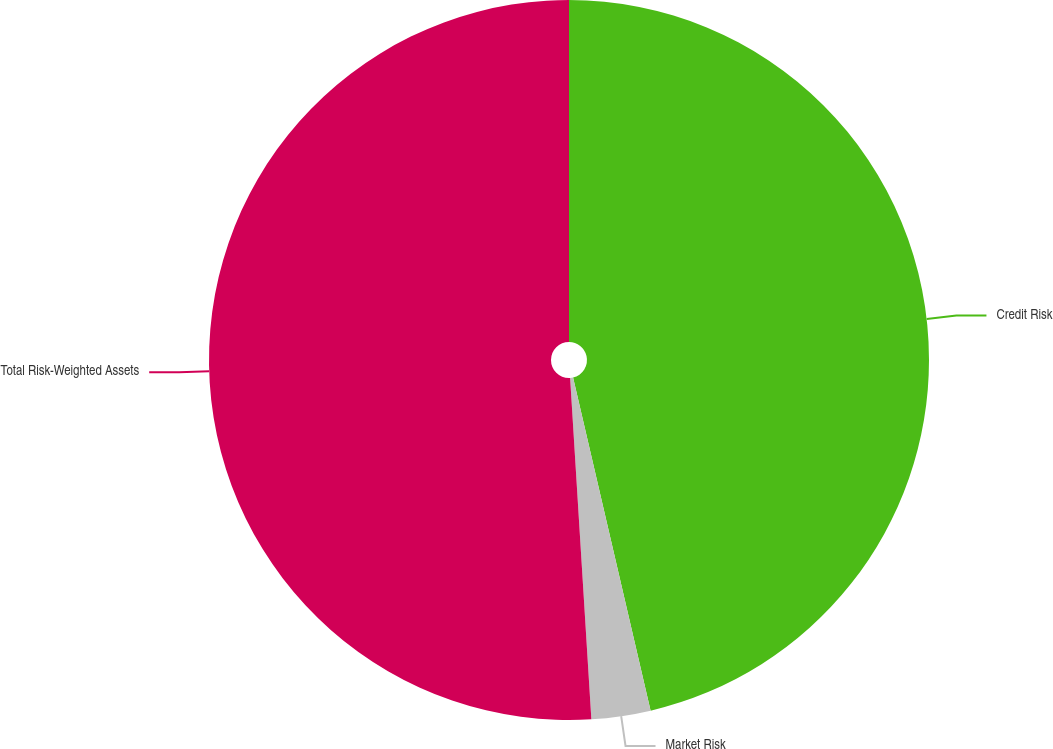Convert chart. <chart><loc_0><loc_0><loc_500><loc_500><pie_chart><fcel>Credit Risk<fcel>Market Risk<fcel>Total Risk-Weighted Assets<nl><fcel>46.36%<fcel>2.65%<fcel>50.99%<nl></chart> 